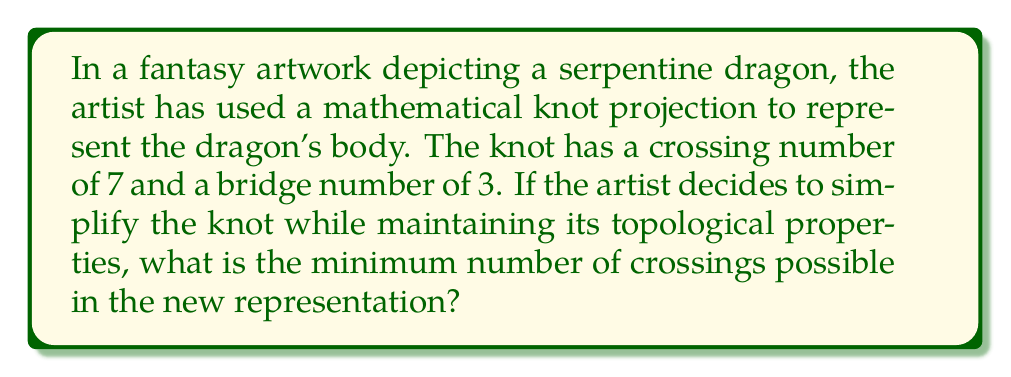Can you solve this math problem? To answer this question, we need to consider the relationship between crossing numbers and bridge numbers in knot theory, and how they relate to the minimal crossing number of a knot.

Step 1: Understand the given information
- The current knot has a crossing number of 7
- The knot has a bridge number of 3

Step 2: Recall the relationship between bridge number and minimal crossing number
In knot theory, there's a theorem that states:
$$ c(K) \geq 2b(K) - 2 $$
Where $c(K)$ is the minimal crossing number and $b(K)$ is the bridge number of the knot K.

Step 3: Apply the theorem to our scenario
Given that the bridge number $b(K) = 3$, we can calculate the lower bound for the minimal crossing number:
$$ c(K) \geq 2(3) - 2 $$
$$ c(K) \geq 6 - 2 $$
$$ c(K) \geq 4 $$

Step 4: Consider the current crossing number
The current representation has 7 crossings, which is already a relatively simple representation. However, the inequality shows that it might be possible to reduce the number of crossings to as low as 4 while maintaining the same topological properties (including the bridge number).

Step 5: Determine the minimum possible crossings
Since the minimal crossing number must be an integer, and it must satisfy the inequality $c(K) \geq 4$, the minimum number of crossings possible in the new representation is 4.
Answer: 4 